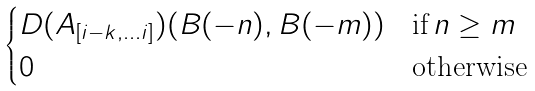Convert formula to latex. <formula><loc_0><loc_0><loc_500><loc_500>\begin{cases} D ( \AA A _ { [ i - k , \dots i ] } ) ( B ( - n ) , B ( - m ) ) & \text {if} \, n \geq m \\ 0 & \text {otherwise} \end{cases}</formula> 